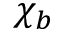Convert formula to latex. <formula><loc_0><loc_0><loc_500><loc_500>\chi _ { b }</formula> 